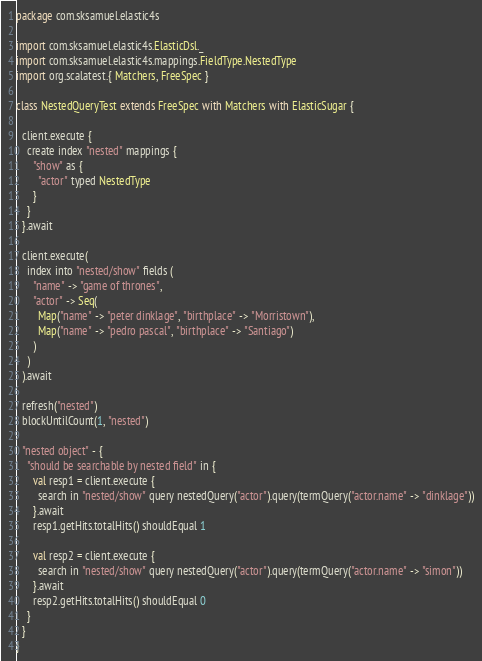Convert code to text. <code><loc_0><loc_0><loc_500><loc_500><_Scala_>package com.sksamuel.elastic4s

import com.sksamuel.elastic4s.ElasticDsl._
import com.sksamuel.elastic4s.mappings.FieldType.NestedType
import org.scalatest.{ Matchers, FreeSpec }

class NestedQueryTest extends FreeSpec with Matchers with ElasticSugar {

  client.execute {
    create index "nested" mappings {
      "show" as {
        "actor" typed NestedType
      }
    }
  }.await

  client.execute(
    index into "nested/show" fields (
      "name" -> "game of thrones",
      "actor" -> Seq(
        Map("name" -> "peter dinklage", "birthplace" -> "Morristown"),
        Map("name" -> "pedro pascal", "birthplace" -> "Santiago")
      )
    )
  ).await

  refresh("nested")
  blockUntilCount(1, "nested")

  "nested object" - {
    "should be searchable by nested field" in {
      val resp1 = client.execute {
        search in "nested/show" query nestedQuery("actor").query(termQuery("actor.name" -> "dinklage"))
      }.await
      resp1.getHits.totalHits() shouldEqual 1

      val resp2 = client.execute {
        search in "nested/show" query nestedQuery("actor").query(termQuery("actor.name" -> "simon"))
      }.await
      resp2.getHits.totalHits() shouldEqual 0
    }
  }
}
</code> 